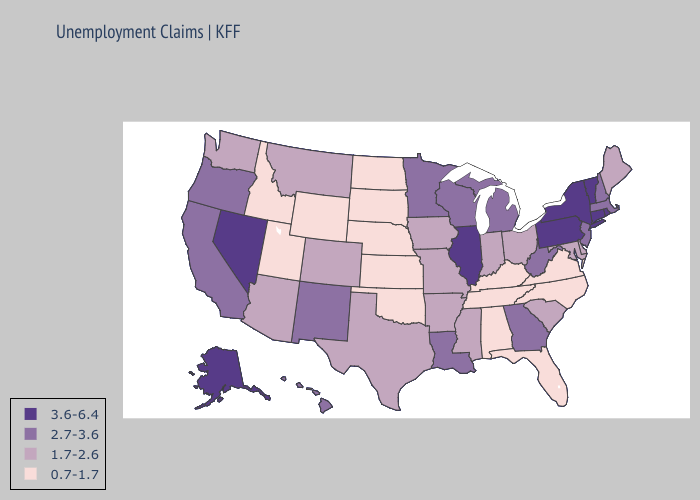Among the states that border Missouri , does Illinois have the lowest value?
Give a very brief answer. No. Does New Mexico have a higher value than Minnesota?
Write a very short answer. No. Among the states that border Oklahoma , does Kansas have the lowest value?
Quick response, please. Yes. Which states have the lowest value in the USA?
Give a very brief answer. Alabama, Florida, Idaho, Kansas, Kentucky, Nebraska, North Carolina, North Dakota, Oklahoma, South Dakota, Tennessee, Utah, Virginia, Wyoming. Name the states that have a value in the range 2.7-3.6?
Give a very brief answer. California, Georgia, Hawaii, Louisiana, Massachusetts, Michigan, Minnesota, New Hampshire, New Jersey, New Mexico, Oregon, West Virginia, Wisconsin. What is the highest value in the MidWest ?
Be succinct. 3.6-6.4. What is the value of Montana?
Short answer required. 1.7-2.6. What is the highest value in states that border Oklahoma?
Answer briefly. 2.7-3.6. Does Massachusetts have the highest value in the USA?
Short answer required. No. Name the states that have a value in the range 0.7-1.7?
Write a very short answer. Alabama, Florida, Idaho, Kansas, Kentucky, Nebraska, North Carolina, North Dakota, Oklahoma, South Dakota, Tennessee, Utah, Virginia, Wyoming. Does the map have missing data?
Keep it brief. No. Does the first symbol in the legend represent the smallest category?
Write a very short answer. No. Name the states that have a value in the range 3.6-6.4?
Give a very brief answer. Alaska, Connecticut, Illinois, Nevada, New York, Pennsylvania, Rhode Island, Vermont. Does the map have missing data?
Quick response, please. No. Name the states that have a value in the range 1.7-2.6?
Write a very short answer. Arizona, Arkansas, Colorado, Delaware, Indiana, Iowa, Maine, Maryland, Mississippi, Missouri, Montana, Ohio, South Carolina, Texas, Washington. 